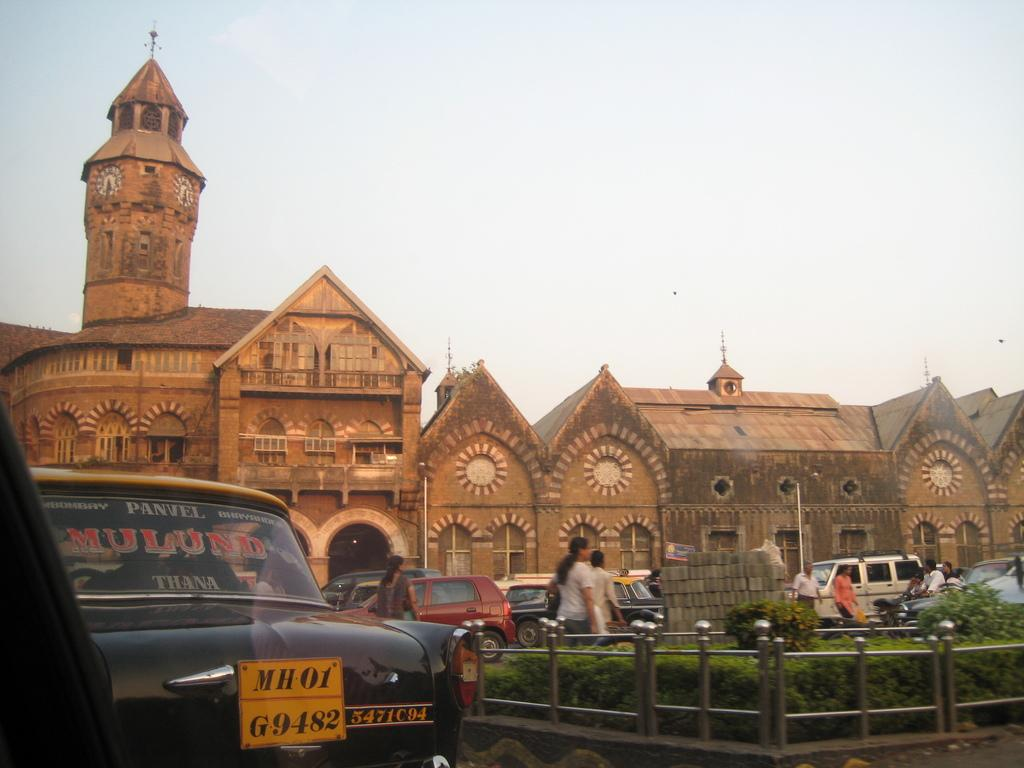What is located in the foreground of the image? There is a car, railing, and plants in the foreground of the image. What can be seen in the background of the image? In the background of the image, there are bricks, vehicles, persons moving on the road, a building, and the sky. What type of material is visible in the background of the image? Bricks are visible in the background of the image. What is the primary mode of transportation in the background of the image? Vehicles are present in the background of the image. What is the natural element visible in the background of the image? The sky is visible in the background of the image. What type of powder is being used by the cook in the image? There is no cook or powder present in the image. What type of place is depicted in the image? The image does not depict a specific place; it shows a car, railing, plants, bricks, vehicles, persons moving on the road, a building, and the sky. 